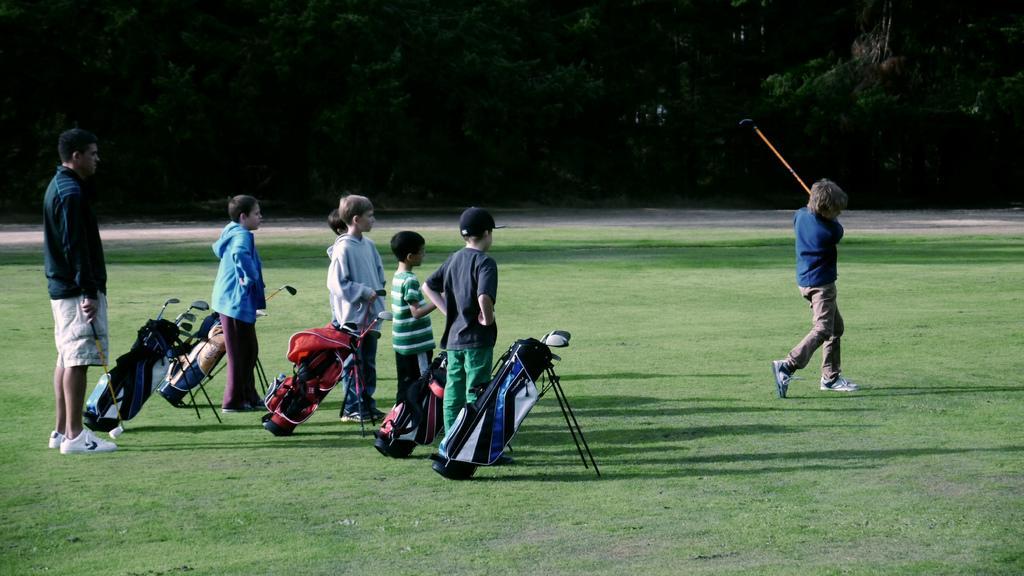In one or two sentences, can you explain what this image depicts? There are group of people standing. I can see a boy standing and holding a golf stick. These are the golf kit bags, which are placed on the grass. In the background, I can see the trees. 